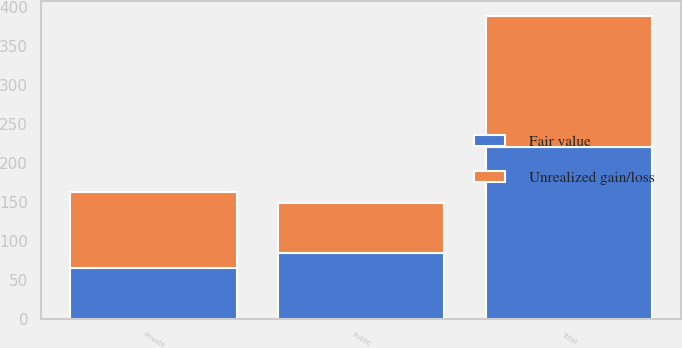Convert chart to OTSL. <chart><loc_0><loc_0><loc_500><loc_500><stacked_bar_chart><ecel><fcel>Public<fcel>Private<fcel>Total<nl><fcel>Fair value<fcel>84<fcel>65<fcel>220<nl><fcel>Unrealized gain/loss<fcel>64<fcel>97<fcel>168<nl></chart> 